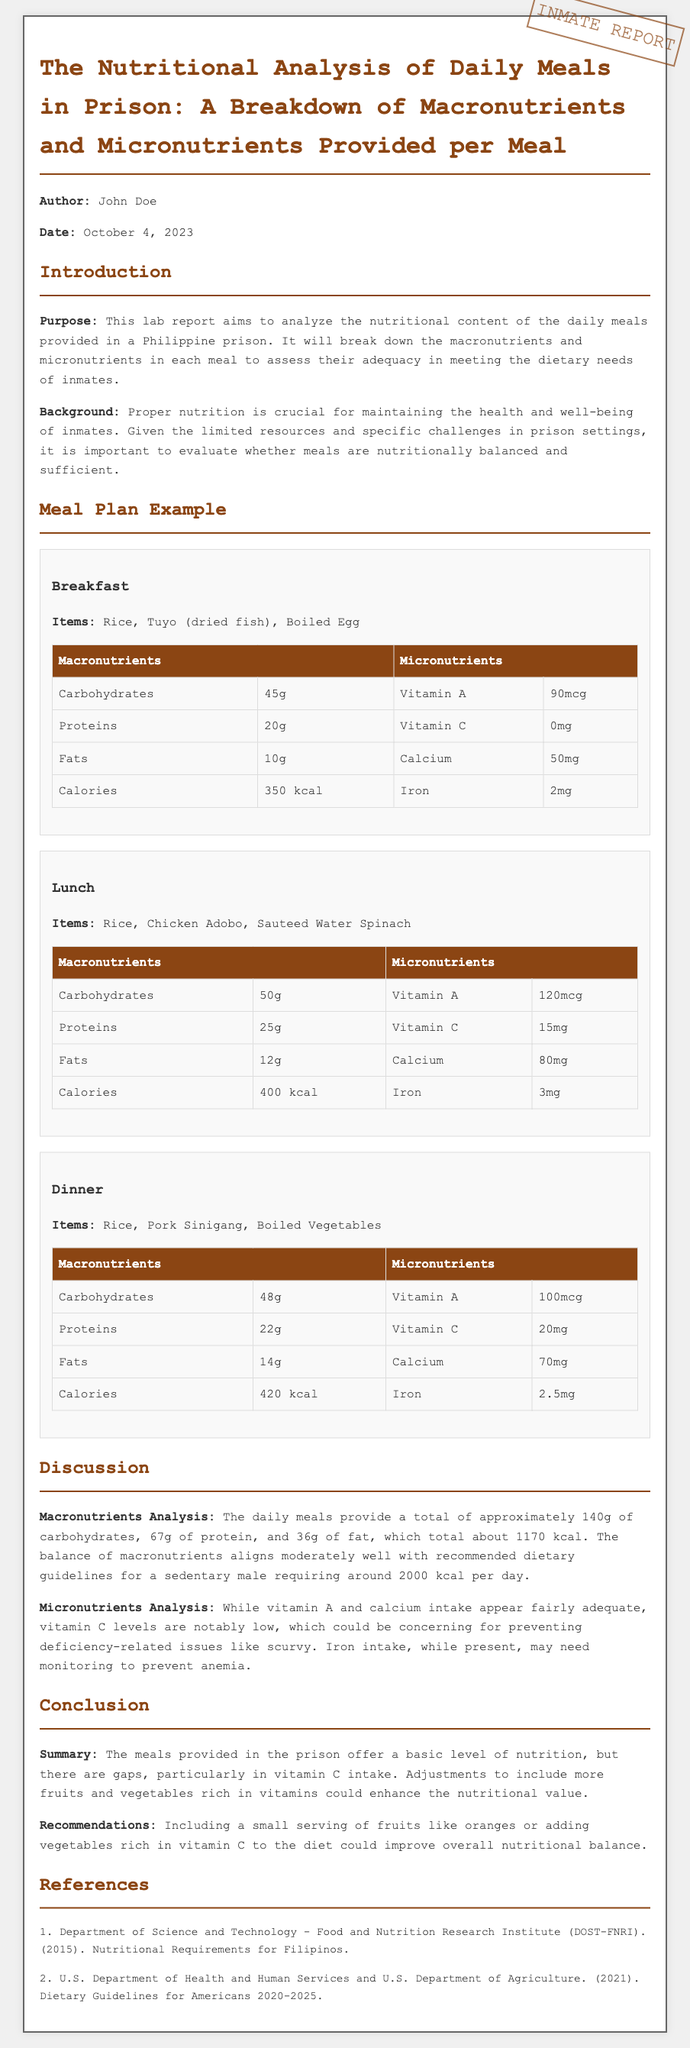what is the title of the report? The title of the report is stated at the top of the document as "The Nutritional Analysis of Daily Meals in Prison: A Breakdown of Macronutrients and Micronutrients Provided per Meal."
Answer: The Nutritional Analysis of Daily Meals in Prison: A Breakdown of Macronutrients and Micronutrients Provided per Meal who is the author of the report? The report specifies the author as "John Doe."
Answer: John Doe what is the main purpose of the report? The purpose of the report, as mentioned in the introduction, is to analyze the nutritional content of daily meals in prison.
Answer: Analyze the nutritional content of daily meals in prison how many grams of protein are provided in lunch? The lunch meal table shows that the protein content is 25 grams.
Answer: 25g what is the total calorie intake for breakfast? The breakfast meal table indicates that the total calorie intake is 350 kcal.
Answer: 350 kcal what is a key micronutrient that is notably low in the meals? The discussion section highlights that vitamin C levels are notably low.
Answer: Vitamin C how much calcium is provided in dinner? The dinner meal table shows that calcium content is 70 mg.
Answer: 70mg what is the total amount of carbohydrates provided per day? The discussion summarizes the total carbohydrates from breakfast, lunch, and dinner, which is 140 grams.
Answer: 140g what adjustments are recommended to improve nutritional quality? The conclusion section recommends including a small serving of fruits rich in vitamin C.
Answer: Including a small serving of fruits 